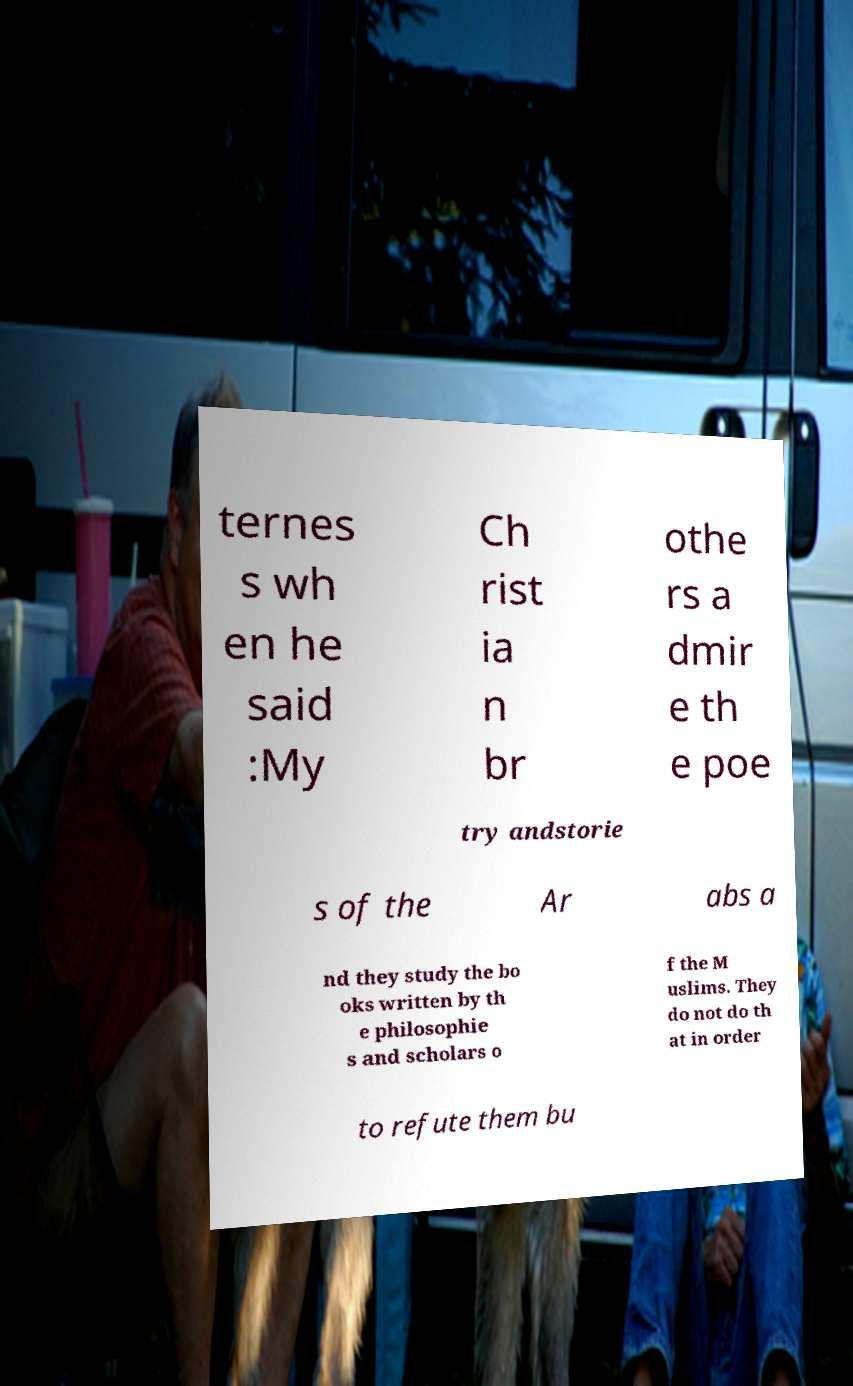Please read and relay the text visible in this image. What does it say? ternes s wh en he said :My Ch rist ia n br othe rs a dmir e th e poe try andstorie s of the Ar abs a nd they study the bo oks written by th e philosophie s and scholars o f the M uslims. They do not do th at in order to refute them bu 